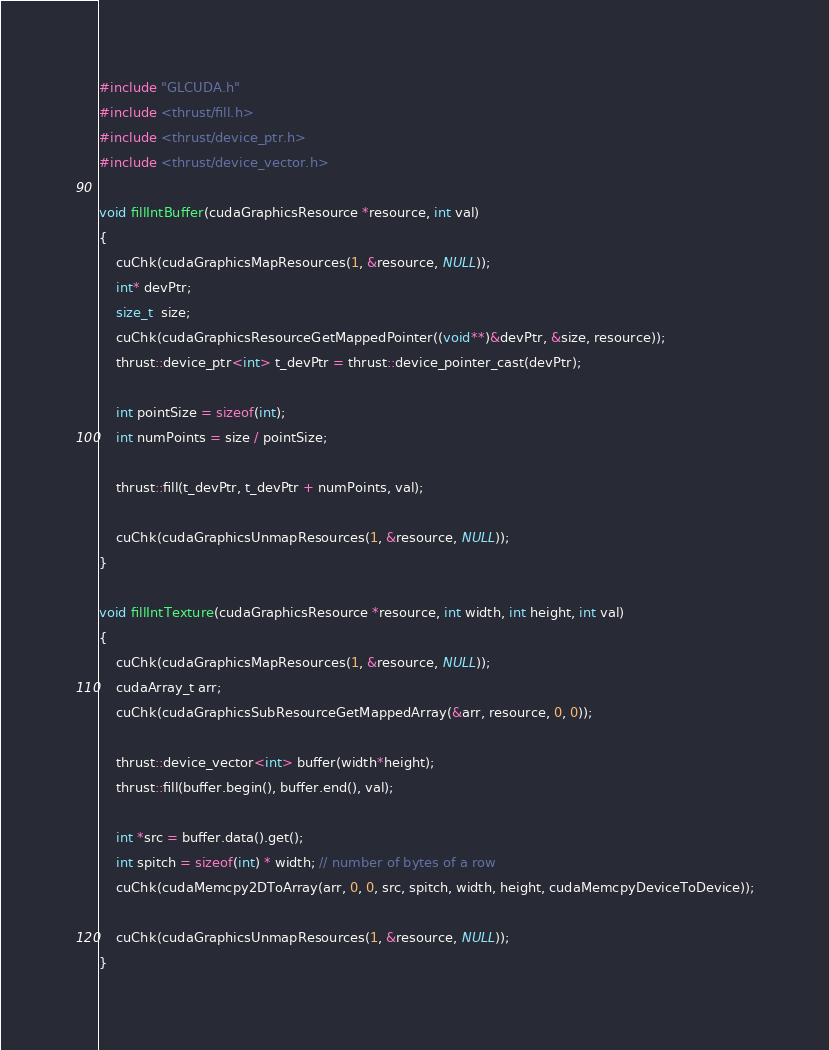<code> <loc_0><loc_0><loc_500><loc_500><_Cuda_>#include "GLCUDA.h"
#include <thrust/fill.h>
#include <thrust/device_ptr.h>
#include <thrust/device_vector.h>

void fillIntBuffer(cudaGraphicsResource *resource, int val)
{
	cuChk(cudaGraphicsMapResources(1, &resource, NULL));
	int* devPtr;
	size_t  size;
	cuChk(cudaGraphicsResourceGetMappedPointer((void**)&devPtr, &size, resource));
	thrust::device_ptr<int> t_devPtr = thrust::device_pointer_cast(devPtr);

	int pointSize = sizeof(int);
	int numPoints = size / pointSize;

	thrust::fill(t_devPtr, t_devPtr + numPoints, val);

	cuChk(cudaGraphicsUnmapResources(1, &resource, NULL));
}

void fillIntTexture(cudaGraphicsResource *resource, int width, int height, int val)
{
	cuChk(cudaGraphicsMapResources(1, &resource, NULL));
	cudaArray_t arr;
	cuChk(cudaGraphicsSubResourceGetMappedArray(&arr, resource, 0, 0));

	thrust::device_vector<int> buffer(width*height);
	thrust::fill(buffer.begin(), buffer.end(), val);
	
	int *src = buffer.data().get();
	int spitch = sizeof(int) * width; // number of bytes of a row
	cuChk(cudaMemcpy2DToArray(arr, 0, 0, src, spitch, width, height, cudaMemcpyDeviceToDevice));

	cuChk(cudaGraphicsUnmapResources(1, &resource, NULL));
}
</code> 